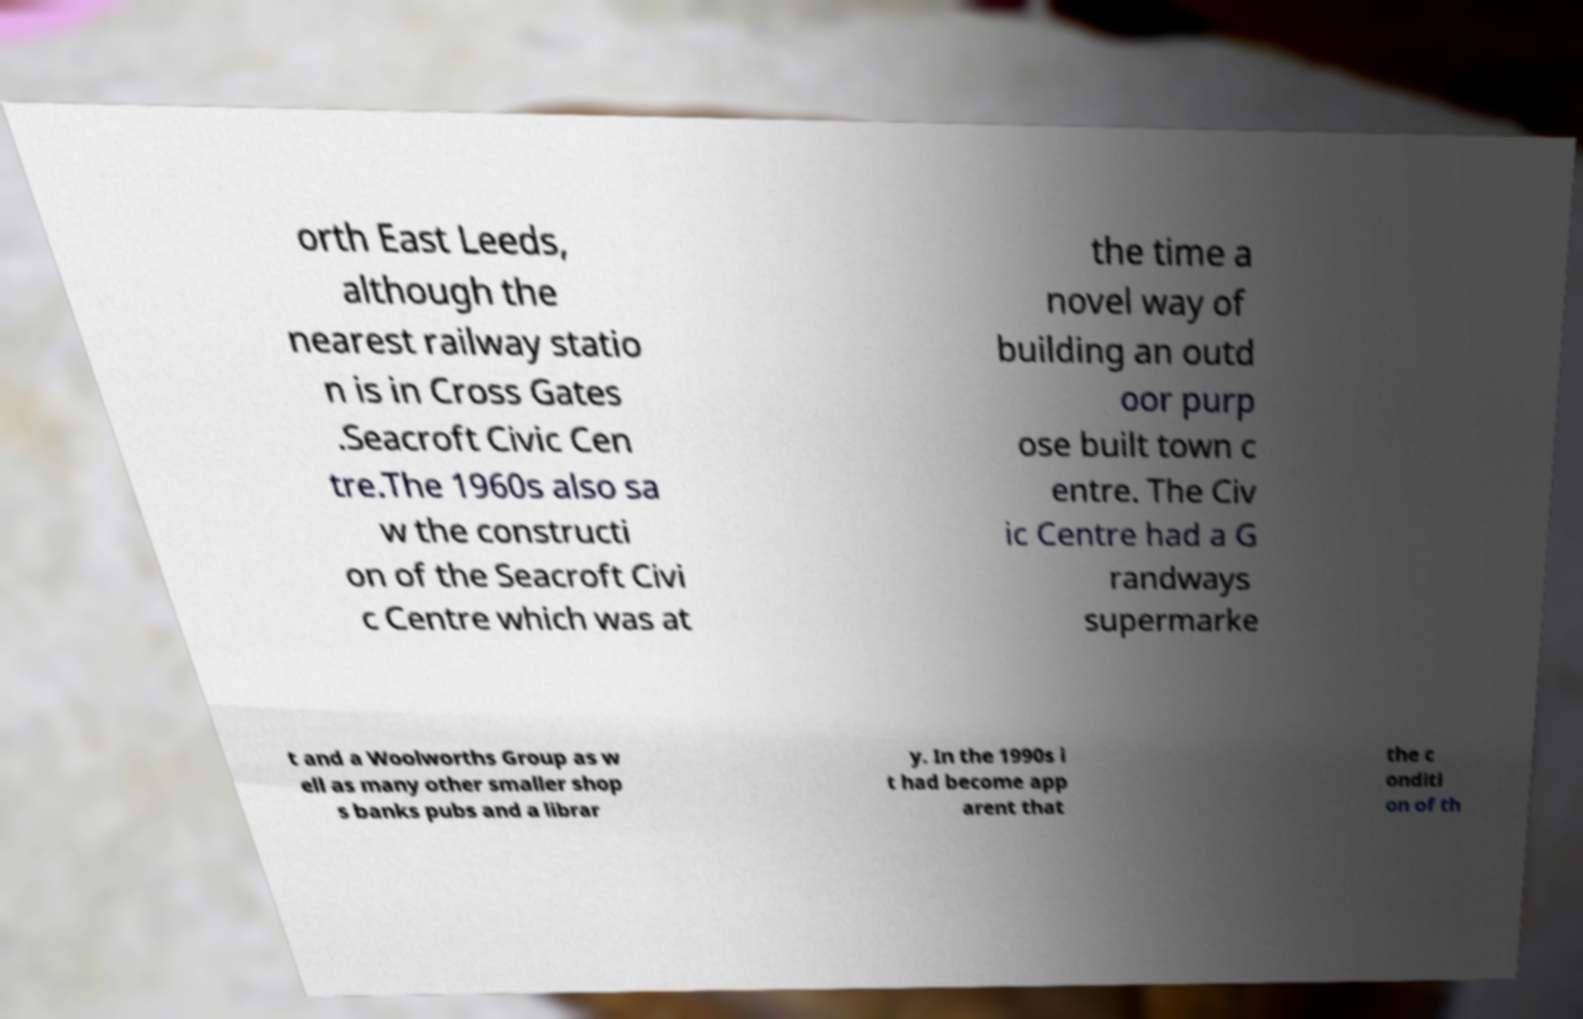Could you assist in decoding the text presented in this image and type it out clearly? orth East Leeds, although the nearest railway statio n is in Cross Gates .Seacroft Civic Cen tre.The 1960s also sa w the constructi on of the Seacroft Civi c Centre which was at the time a novel way of building an outd oor purp ose built town c entre. The Civ ic Centre had a G randways supermarke t and a Woolworths Group as w ell as many other smaller shop s banks pubs and a librar y. In the 1990s i t had become app arent that the c onditi on of th 